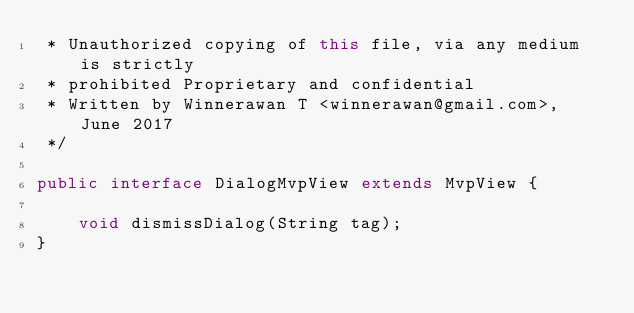<code> <loc_0><loc_0><loc_500><loc_500><_Java_> * Unauthorized copying of this file, via any medium is strictly
 * prohibited Proprietary and confidential
 * Written by Winnerawan T <winnerawan@gmail.com>, June 2017
 */

public interface DialogMvpView extends MvpView {

    void dismissDialog(String tag);
}
</code> 